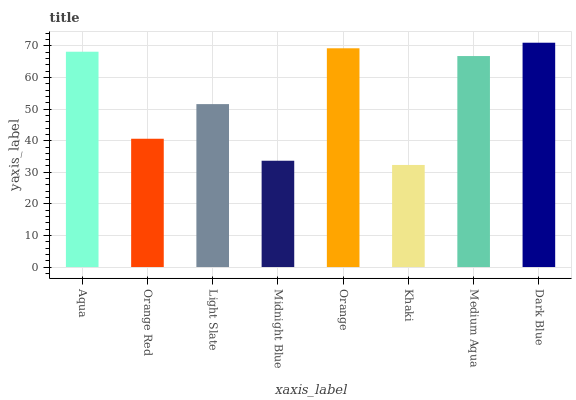Is Orange Red the minimum?
Answer yes or no. No. Is Orange Red the maximum?
Answer yes or no. No. Is Aqua greater than Orange Red?
Answer yes or no. Yes. Is Orange Red less than Aqua?
Answer yes or no. Yes. Is Orange Red greater than Aqua?
Answer yes or no. No. Is Aqua less than Orange Red?
Answer yes or no. No. Is Medium Aqua the high median?
Answer yes or no. Yes. Is Light Slate the low median?
Answer yes or no. Yes. Is Aqua the high median?
Answer yes or no. No. Is Khaki the low median?
Answer yes or no. No. 